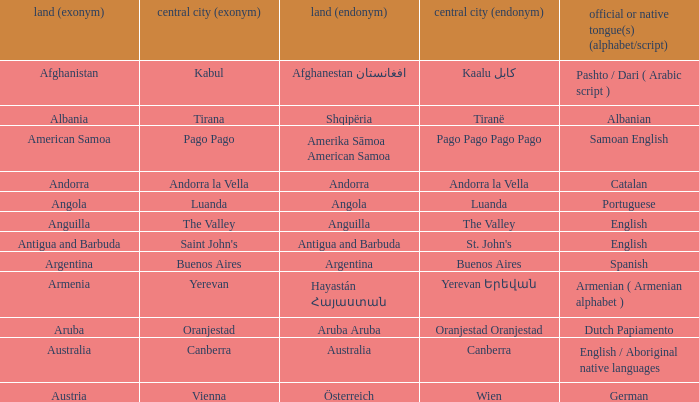Write the full table. {'header': ['land (exonym)', 'central city (exonym)', 'land (endonym)', 'central city (endonym)', 'official or native tongue(s) (alphabet/script)'], 'rows': [['Afghanistan', 'Kabul', 'Afghanestan افغانستان', 'Kaalu كابل', 'Pashto / Dari ( Arabic script )'], ['Albania', 'Tirana', 'Shqipëria', 'Tiranë', 'Albanian'], ['American Samoa', 'Pago Pago', 'Amerika Sāmoa American Samoa', 'Pago Pago Pago Pago', 'Samoan English'], ['Andorra', 'Andorra la Vella', 'Andorra', 'Andorra la Vella', 'Catalan'], ['Angola', 'Luanda', 'Angola', 'Luanda', 'Portuguese'], ['Anguilla', 'The Valley', 'Anguilla', 'The Valley', 'English'], ['Antigua and Barbuda', "Saint John's", 'Antigua and Barbuda', "St. John's", 'English'], ['Argentina', 'Buenos Aires', 'Argentina', 'Buenos Aires', 'Spanish'], ['Armenia', 'Yerevan', 'Hayastán Հայաստան', 'Yerevan Երեվան', 'Armenian ( Armenian alphabet )'], ['Aruba', 'Oranjestad', 'Aruba Aruba', 'Oranjestad Oranjestad', 'Dutch Papiamento'], ['Australia', 'Canberra', 'Australia', 'Canberra', 'English / Aboriginal native languages'], ['Austria', 'Vienna', 'Österreich', 'Wien', 'German']]} What is the English name given to the city of St. John's? Saint John's. 